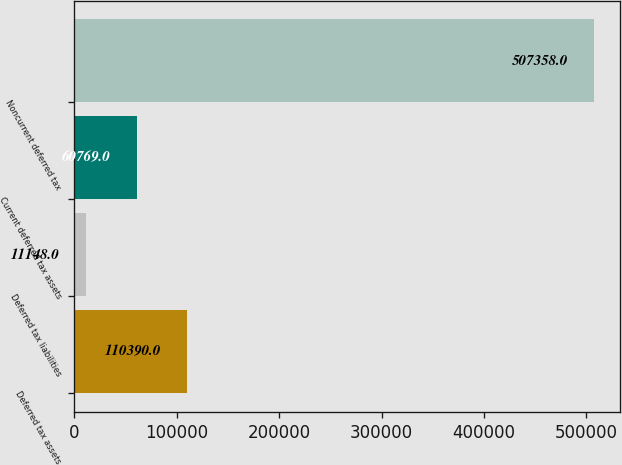<chart> <loc_0><loc_0><loc_500><loc_500><bar_chart><fcel>Deferred tax assets<fcel>Deferred tax liabilities<fcel>Current deferred tax assets<fcel>Noncurrent deferred tax<nl><fcel>110390<fcel>11148<fcel>60769<fcel>507358<nl></chart> 